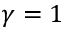<formula> <loc_0><loc_0><loc_500><loc_500>\gamma = 1</formula> 